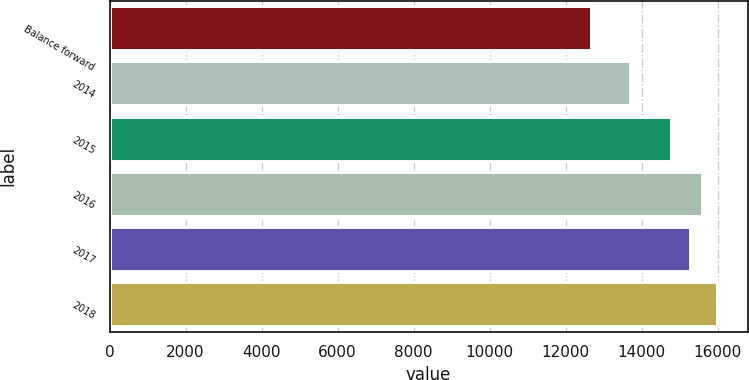Convert chart to OTSL. <chart><loc_0><loc_0><loc_500><loc_500><bar_chart><fcel>Balance forward<fcel>2014<fcel>2015<fcel>2016<fcel>2017<fcel>2018<nl><fcel>12671<fcel>13697<fcel>14762<fcel>15591.9<fcel>15260<fcel>15990<nl></chart> 